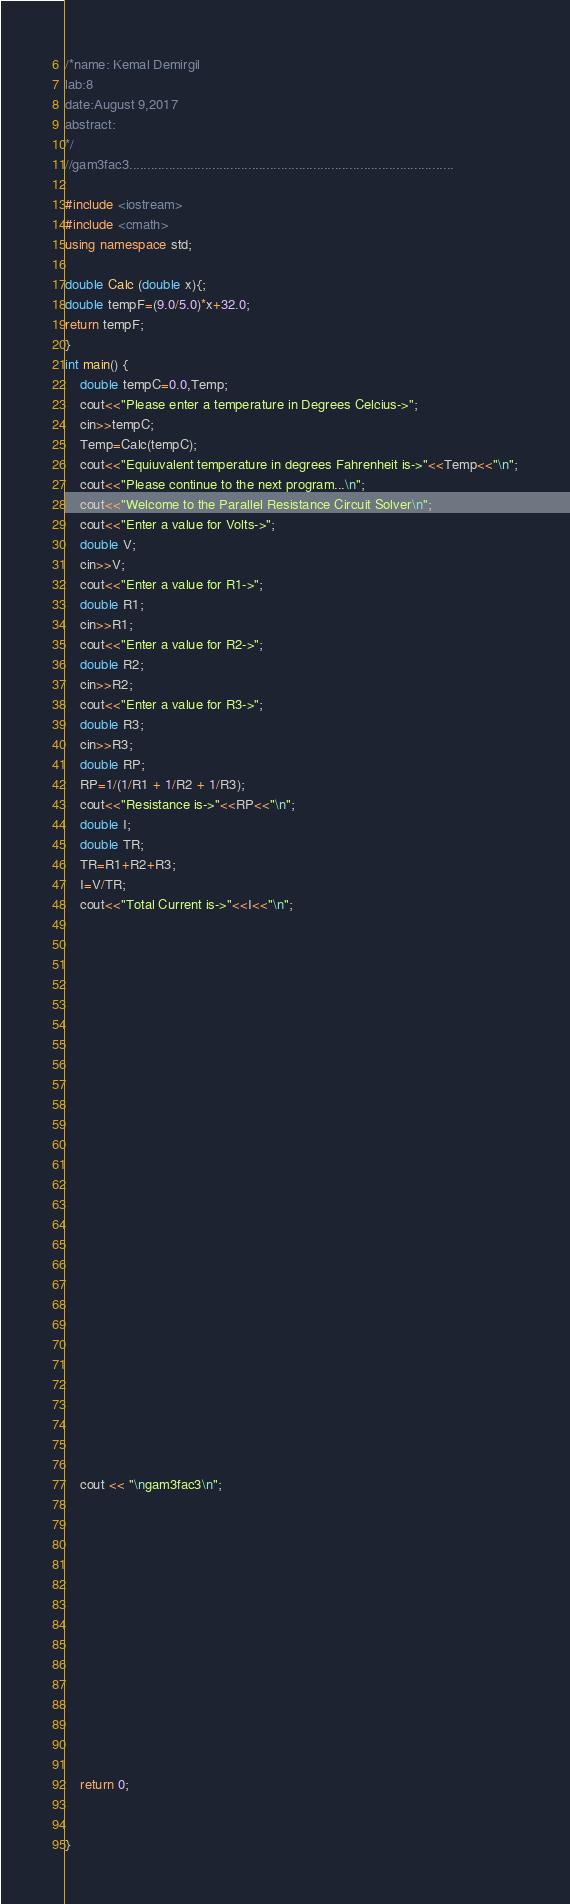<code> <loc_0><loc_0><loc_500><loc_500><_C++_>/*name: Kemal Demirgil
lab:8
date:August 9,2017	
abstract:
*/
//gam3fac3..........................................................................................

#include <iostream>
#include <cmath>
using namespace std;

double Calc (double x){;
double tempF=(9.0/5.0)*x+32.0;
return tempF;
}
int main() {
	double tempC=0.0,Temp;
	cout<<"Please enter a temperature in Degrees Celcius->";
	cin>>tempC;
	Temp=Calc(tempC);
	cout<<"Equiuvalent temperature in degrees Fahrenheit is->"<<Temp<<"\n";
	cout<<"Please continue to the next program...\n";
	cout<<"Welcome to the Parallel Resistance Circuit Solver\n";
	cout<<"Enter a value for Volts->";
	double V;
	cin>>V;
	cout<<"Enter a value for R1->";
	double R1;
	cin>>R1;
	cout<<"Enter a value for R2->";
	double R2;
	cin>>R2;
	cout<<"Enter a value for R3->";
	double R3;
	cin>>R3;
	double RP;
	RP=1/(1/R1 + 1/R2 + 1/R3);
	cout<<"Resistance is->"<<RP<<"\n";
	double I;
	double TR;
	TR=R1+R2+R3;
	I=V/TR;
	cout<<"Total Current is->"<<I<<"\n";
	
	
	
	
























	cout << "\ngam3fac3\n";














	return 0;


}
</code> 